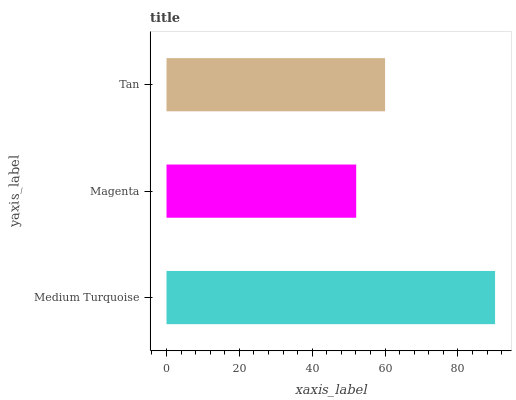Is Magenta the minimum?
Answer yes or no. Yes. Is Medium Turquoise the maximum?
Answer yes or no. Yes. Is Tan the minimum?
Answer yes or no. No. Is Tan the maximum?
Answer yes or no. No. Is Tan greater than Magenta?
Answer yes or no. Yes. Is Magenta less than Tan?
Answer yes or no. Yes. Is Magenta greater than Tan?
Answer yes or no. No. Is Tan less than Magenta?
Answer yes or no. No. Is Tan the high median?
Answer yes or no. Yes. Is Tan the low median?
Answer yes or no. Yes. Is Medium Turquoise the high median?
Answer yes or no. No. Is Medium Turquoise the low median?
Answer yes or no. No. 